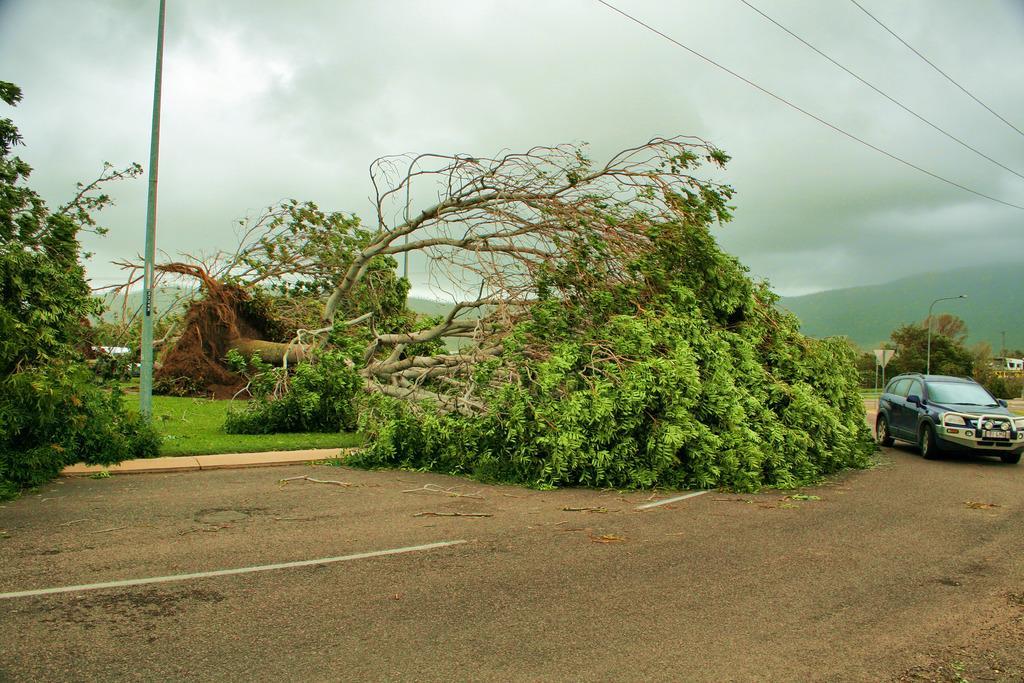Describe this image in one or two sentences. In this image I can see road and on it I can see a vehicle and few trees. I can also see grass, a pole, few wires and white lines on road. In the background I can see a street light, few more trees, few buildings and cloudy sky. 